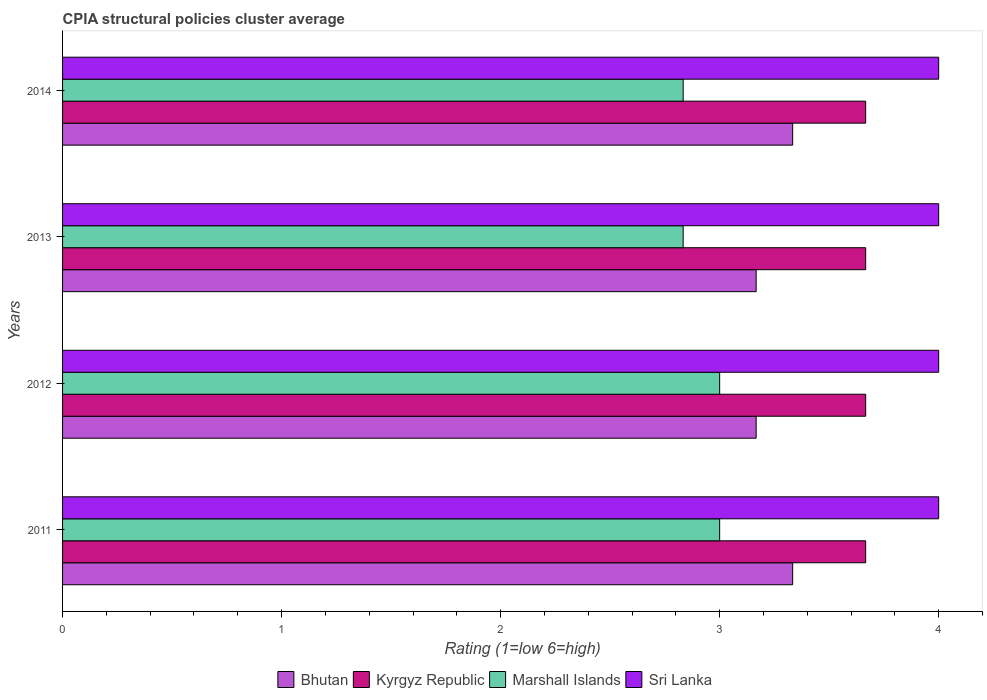How many groups of bars are there?
Keep it short and to the point. 4. Are the number of bars per tick equal to the number of legend labels?
Make the answer very short. Yes. How many bars are there on the 4th tick from the bottom?
Ensure brevity in your answer.  4. What is the label of the 1st group of bars from the top?
Provide a succinct answer. 2014. In how many cases, is the number of bars for a given year not equal to the number of legend labels?
Provide a short and direct response. 0. What is the CPIA rating in Sri Lanka in 2014?
Keep it short and to the point. 4. Across all years, what is the maximum CPIA rating in Sri Lanka?
Make the answer very short. 4. Across all years, what is the minimum CPIA rating in Bhutan?
Ensure brevity in your answer.  3.17. In which year was the CPIA rating in Kyrgyz Republic maximum?
Keep it short and to the point. 2014. What is the difference between the CPIA rating in Kyrgyz Republic in 2012 and that in 2014?
Give a very brief answer. -3.333333329802457e-6. What is the difference between the CPIA rating in Sri Lanka in 2011 and the CPIA rating in Bhutan in 2012?
Make the answer very short. 0.83. What is the average CPIA rating in Marshall Islands per year?
Ensure brevity in your answer.  2.92. In the year 2014, what is the difference between the CPIA rating in Bhutan and CPIA rating in Sri Lanka?
Keep it short and to the point. -0.67. In how many years, is the CPIA rating in Marshall Islands greater than 1.4 ?
Keep it short and to the point. 4. What is the ratio of the CPIA rating in Marshall Islands in 2011 to that in 2014?
Provide a short and direct response. 1.06. Is the CPIA rating in Marshall Islands in 2012 less than that in 2013?
Make the answer very short. No. In how many years, is the CPIA rating in Marshall Islands greater than the average CPIA rating in Marshall Islands taken over all years?
Make the answer very short. 2. Is it the case that in every year, the sum of the CPIA rating in Kyrgyz Republic and CPIA rating in Marshall Islands is greater than the sum of CPIA rating in Bhutan and CPIA rating in Sri Lanka?
Give a very brief answer. No. What does the 2nd bar from the top in 2013 represents?
Keep it short and to the point. Marshall Islands. What does the 2nd bar from the bottom in 2012 represents?
Give a very brief answer. Kyrgyz Republic. How many years are there in the graph?
Ensure brevity in your answer.  4. Are the values on the major ticks of X-axis written in scientific E-notation?
Make the answer very short. No. Does the graph contain any zero values?
Offer a very short reply. No. Where does the legend appear in the graph?
Ensure brevity in your answer.  Bottom center. How many legend labels are there?
Your answer should be compact. 4. What is the title of the graph?
Your response must be concise. CPIA structural policies cluster average. What is the label or title of the X-axis?
Your answer should be compact. Rating (1=low 6=high). What is the label or title of the Y-axis?
Ensure brevity in your answer.  Years. What is the Rating (1=low 6=high) of Bhutan in 2011?
Ensure brevity in your answer.  3.33. What is the Rating (1=low 6=high) of Kyrgyz Republic in 2011?
Keep it short and to the point. 3.67. What is the Rating (1=low 6=high) in Sri Lanka in 2011?
Your answer should be very brief. 4. What is the Rating (1=low 6=high) in Bhutan in 2012?
Your answer should be very brief. 3.17. What is the Rating (1=low 6=high) of Kyrgyz Republic in 2012?
Offer a terse response. 3.67. What is the Rating (1=low 6=high) of Bhutan in 2013?
Provide a short and direct response. 3.17. What is the Rating (1=low 6=high) of Kyrgyz Republic in 2013?
Provide a short and direct response. 3.67. What is the Rating (1=low 6=high) of Marshall Islands in 2013?
Your answer should be very brief. 2.83. What is the Rating (1=low 6=high) in Sri Lanka in 2013?
Provide a succinct answer. 4. What is the Rating (1=low 6=high) of Bhutan in 2014?
Offer a very short reply. 3.33. What is the Rating (1=low 6=high) of Kyrgyz Republic in 2014?
Provide a short and direct response. 3.67. What is the Rating (1=low 6=high) in Marshall Islands in 2014?
Your answer should be very brief. 2.83. Across all years, what is the maximum Rating (1=low 6=high) of Bhutan?
Your answer should be compact. 3.33. Across all years, what is the maximum Rating (1=low 6=high) in Kyrgyz Republic?
Offer a very short reply. 3.67. Across all years, what is the minimum Rating (1=low 6=high) in Bhutan?
Ensure brevity in your answer.  3.17. Across all years, what is the minimum Rating (1=low 6=high) in Kyrgyz Republic?
Offer a terse response. 3.67. Across all years, what is the minimum Rating (1=low 6=high) in Marshall Islands?
Offer a terse response. 2.83. Across all years, what is the minimum Rating (1=low 6=high) of Sri Lanka?
Provide a short and direct response. 4. What is the total Rating (1=low 6=high) in Kyrgyz Republic in the graph?
Provide a short and direct response. 14.67. What is the total Rating (1=low 6=high) of Marshall Islands in the graph?
Your answer should be compact. 11.67. What is the total Rating (1=low 6=high) of Sri Lanka in the graph?
Keep it short and to the point. 16. What is the difference between the Rating (1=low 6=high) of Kyrgyz Republic in 2011 and that in 2013?
Offer a very short reply. 0. What is the difference between the Rating (1=low 6=high) of Sri Lanka in 2011 and that in 2013?
Keep it short and to the point. 0. What is the difference between the Rating (1=low 6=high) in Bhutan in 2011 and that in 2014?
Your answer should be very brief. 0. What is the difference between the Rating (1=low 6=high) of Marshall Islands in 2012 and that in 2013?
Keep it short and to the point. 0.17. What is the difference between the Rating (1=low 6=high) of Kyrgyz Republic in 2012 and that in 2014?
Ensure brevity in your answer.  -0. What is the difference between the Rating (1=low 6=high) in Bhutan in 2013 and that in 2014?
Provide a short and direct response. -0.17. What is the difference between the Rating (1=low 6=high) of Kyrgyz Republic in 2013 and that in 2014?
Give a very brief answer. -0. What is the difference between the Rating (1=low 6=high) in Marshall Islands in 2013 and that in 2014?
Ensure brevity in your answer.  0. What is the difference between the Rating (1=low 6=high) in Bhutan in 2011 and the Rating (1=low 6=high) in Kyrgyz Republic in 2012?
Your response must be concise. -0.33. What is the difference between the Rating (1=low 6=high) in Bhutan in 2011 and the Rating (1=low 6=high) in Marshall Islands in 2012?
Provide a short and direct response. 0.33. What is the difference between the Rating (1=low 6=high) of Bhutan in 2011 and the Rating (1=low 6=high) of Sri Lanka in 2012?
Offer a very short reply. -0.67. What is the difference between the Rating (1=low 6=high) in Marshall Islands in 2011 and the Rating (1=low 6=high) in Sri Lanka in 2012?
Make the answer very short. -1. What is the difference between the Rating (1=low 6=high) of Bhutan in 2011 and the Rating (1=low 6=high) of Sri Lanka in 2013?
Ensure brevity in your answer.  -0.67. What is the difference between the Rating (1=low 6=high) in Kyrgyz Republic in 2011 and the Rating (1=low 6=high) in Sri Lanka in 2014?
Give a very brief answer. -0.33. What is the difference between the Rating (1=low 6=high) in Bhutan in 2012 and the Rating (1=low 6=high) in Marshall Islands in 2013?
Provide a short and direct response. 0.33. What is the difference between the Rating (1=low 6=high) of Kyrgyz Republic in 2012 and the Rating (1=low 6=high) of Sri Lanka in 2013?
Ensure brevity in your answer.  -0.33. What is the difference between the Rating (1=low 6=high) of Marshall Islands in 2012 and the Rating (1=low 6=high) of Sri Lanka in 2013?
Offer a very short reply. -1. What is the difference between the Rating (1=low 6=high) of Bhutan in 2012 and the Rating (1=low 6=high) of Kyrgyz Republic in 2014?
Your answer should be very brief. -0.5. What is the difference between the Rating (1=low 6=high) in Bhutan in 2012 and the Rating (1=low 6=high) in Marshall Islands in 2014?
Offer a terse response. 0.33. What is the difference between the Rating (1=low 6=high) of Bhutan in 2012 and the Rating (1=low 6=high) of Sri Lanka in 2014?
Offer a terse response. -0.83. What is the difference between the Rating (1=low 6=high) of Marshall Islands in 2012 and the Rating (1=low 6=high) of Sri Lanka in 2014?
Your answer should be very brief. -1. What is the difference between the Rating (1=low 6=high) of Bhutan in 2013 and the Rating (1=low 6=high) of Kyrgyz Republic in 2014?
Provide a short and direct response. -0.5. What is the difference between the Rating (1=low 6=high) in Bhutan in 2013 and the Rating (1=low 6=high) in Marshall Islands in 2014?
Keep it short and to the point. 0.33. What is the difference between the Rating (1=low 6=high) in Bhutan in 2013 and the Rating (1=low 6=high) in Sri Lanka in 2014?
Ensure brevity in your answer.  -0.83. What is the difference between the Rating (1=low 6=high) in Kyrgyz Republic in 2013 and the Rating (1=low 6=high) in Sri Lanka in 2014?
Provide a succinct answer. -0.33. What is the difference between the Rating (1=low 6=high) in Marshall Islands in 2013 and the Rating (1=low 6=high) in Sri Lanka in 2014?
Offer a terse response. -1.17. What is the average Rating (1=low 6=high) in Bhutan per year?
Give a very brief answer. 3.25. What is the average Rating (1=low 6=high) of Kyrgyz Republic per year?
Give a very brief answer. 3.67. What is the average Rating (1=low 6=high) of Marshall Islands per year?
Your answer should be compact. 2.92. In the year 2011, what is the difference between the Rating (1=low 6=high) of Bhutan and Rating (1=low 6=high) of Sri Lanka?
Your answer should be compact. -0.67. In the year 2011, what is the difference between the Rating (1=low 6=high) of Kyrgyz Republic and Rating (1=low 6=high) of Sri Lanka?
Your answer should be compact. -0.33. In the year 2012, what is the difference between the Rating (1=low 6=high) in Bhutan and Rating (1=low 6=high) in Marshall Islands?
Your answer should be compact. 0.17. In the year 2012, what is the difference between the Rating (1=low 6=high) of Bhutan and Rating (1=low 6=high) of Sri Lanka?
Make the answer very short. -0.83. In the year 2012, what is the difference between the Rating (1=low 6=high) in Kyrgyz Republic and Rating (1=low 6=high) in Sri Lanka?
Your response must be concise. -0.33. In the year 2012, what is the difference between the Rating (1=low 6=high) in Marshall Islands and Rating (1=low 6=high) in Sri Lanka?
Your response must be concise. -1. In the year 2013, what is the difference between the Rating (1=low 6=high) of Bhutan and Rating (1=low 6=high) of Sri Lanka?
Keep it short and to the point. -0.83. In the year 2013, what is the difference between the Rating (1=low 6=high) in Kyrgyz Republic and Rating (1=low 6=high) in Sri Lanka?
Your answer should be compact. -0.33. In the year 2013, what is the difference between the Rating (1=low 6=high) of Marshall Islands and Rating (1=low 6=high) of Sri Lanka?
Offer a terse response. -1.17. In the year 2014, what is the difference between the Rating (1=low 6=high) of Bhutan and Rating (1=low 6=high) of Kyrgyz Republic?
Offer a very short reply. -0.33. In the year 2014, what is the difference between the Rating (1=low 6=high) of Bhutan and Rating (1=low 6=high) of Marshall Islands?
Provide a succinct answer. 0.5. In the year 2014, what is the difference between the Rating (1=low 6=high) of Kyrgyz Republic and Rating (1=low 6=high) of Sri Lanka?
Provide a short and direct response. -0.33. In the year 2014, what is the difference between the Rating (1=low 6=high) in Marshall Islands and Rating (1=low 6=high) in Sri Lanka?
Provide a short and direct response. -1.17. What is the ratio of the Rating (1=low 6=high) in Bhutan in 2011 to that in 2012?
Your answer should be compact. 1.05. What is the ratio of the Rating (1=low 6=high) in Kyrgyz Republic in 2011 to that in 2012?
Give a very brief answer. 1. What is the ratio of the Rating (1=low 6=high) in Bhutan in 2011 to that in 2013?
Give a very brief answer. 1.05. What is the ratio of the Rating (1=low 6=high) in Marshall Islands in 2011 to that in 2013?
Make the answer very short. 1.06. What is the ratio of the Rating (1=low 6=high) of Bhutan in 2011 to that in 2014?
Make the answer very short. 1. What is the ratio of the Rating (1=low 6=high) of Kyrgyz Republic in 2011 to that in 2014?
Offer a very short reply. 1. What is the ratio of the Rating (1=low 6=high) in Marshall Islands in 2011 to that in 2014?
Your response must be concise. 1.06. What is the ratio of the Rating (1=low 6=high) in Sri Lanka in 2011 to that in 2014?
Provide a succinct answer. 1. What is the ratio of the Rating (1=low 6=high) of Marshall Islands in 2012 to that in 2013?
Keep it short and to the point. 1.06. What is the ratio of the Rating (1=low 6=high) of Sri Lanka in 2012 to that in 2013?
Your answer should be very brief. 1. What is the ratio of the Rating (1=low 6=high) of Marshall Islands in 2012 to that in 2014?
Your response must be concise. 1.06. What is the ratio of the Rating (1=low 6=high) of Sri Lanka in 2012 to that in 2014?
Give a very brief answer. 1. What is the ratio of the Rating (1=low 6=high) in Marshall Islands in 2013 to that in 2014?
Offer a very short reply. 1. What is the ratio of the Rating (1=low 6=high) of Sri Lanka in 2013 to that in 2014?
Keep it short and to the point. 1. What is the difference between the highest and the second highest Rating (1=low 6=high) in Bhutan?
Give a very brief answer. 0. What is the difference between the highest and the second highest Rating (1=low 6=high) in Kyrgyz Republic?
Keep it short and to the point. 0. What is the difference between the highest and the second highest Rating (1=low 6=high) in Sri Lanka?
Offer a very short reply. 0. What is the difference between the highest and the lowest Rating (1=low 6=high) in Bhutan?
Offer a terse response. 0.17. What is the difference between the highest and the lowest Rating (1=low 6=high) of Kyrgyz Republic?
Your response must be concise. 0. 